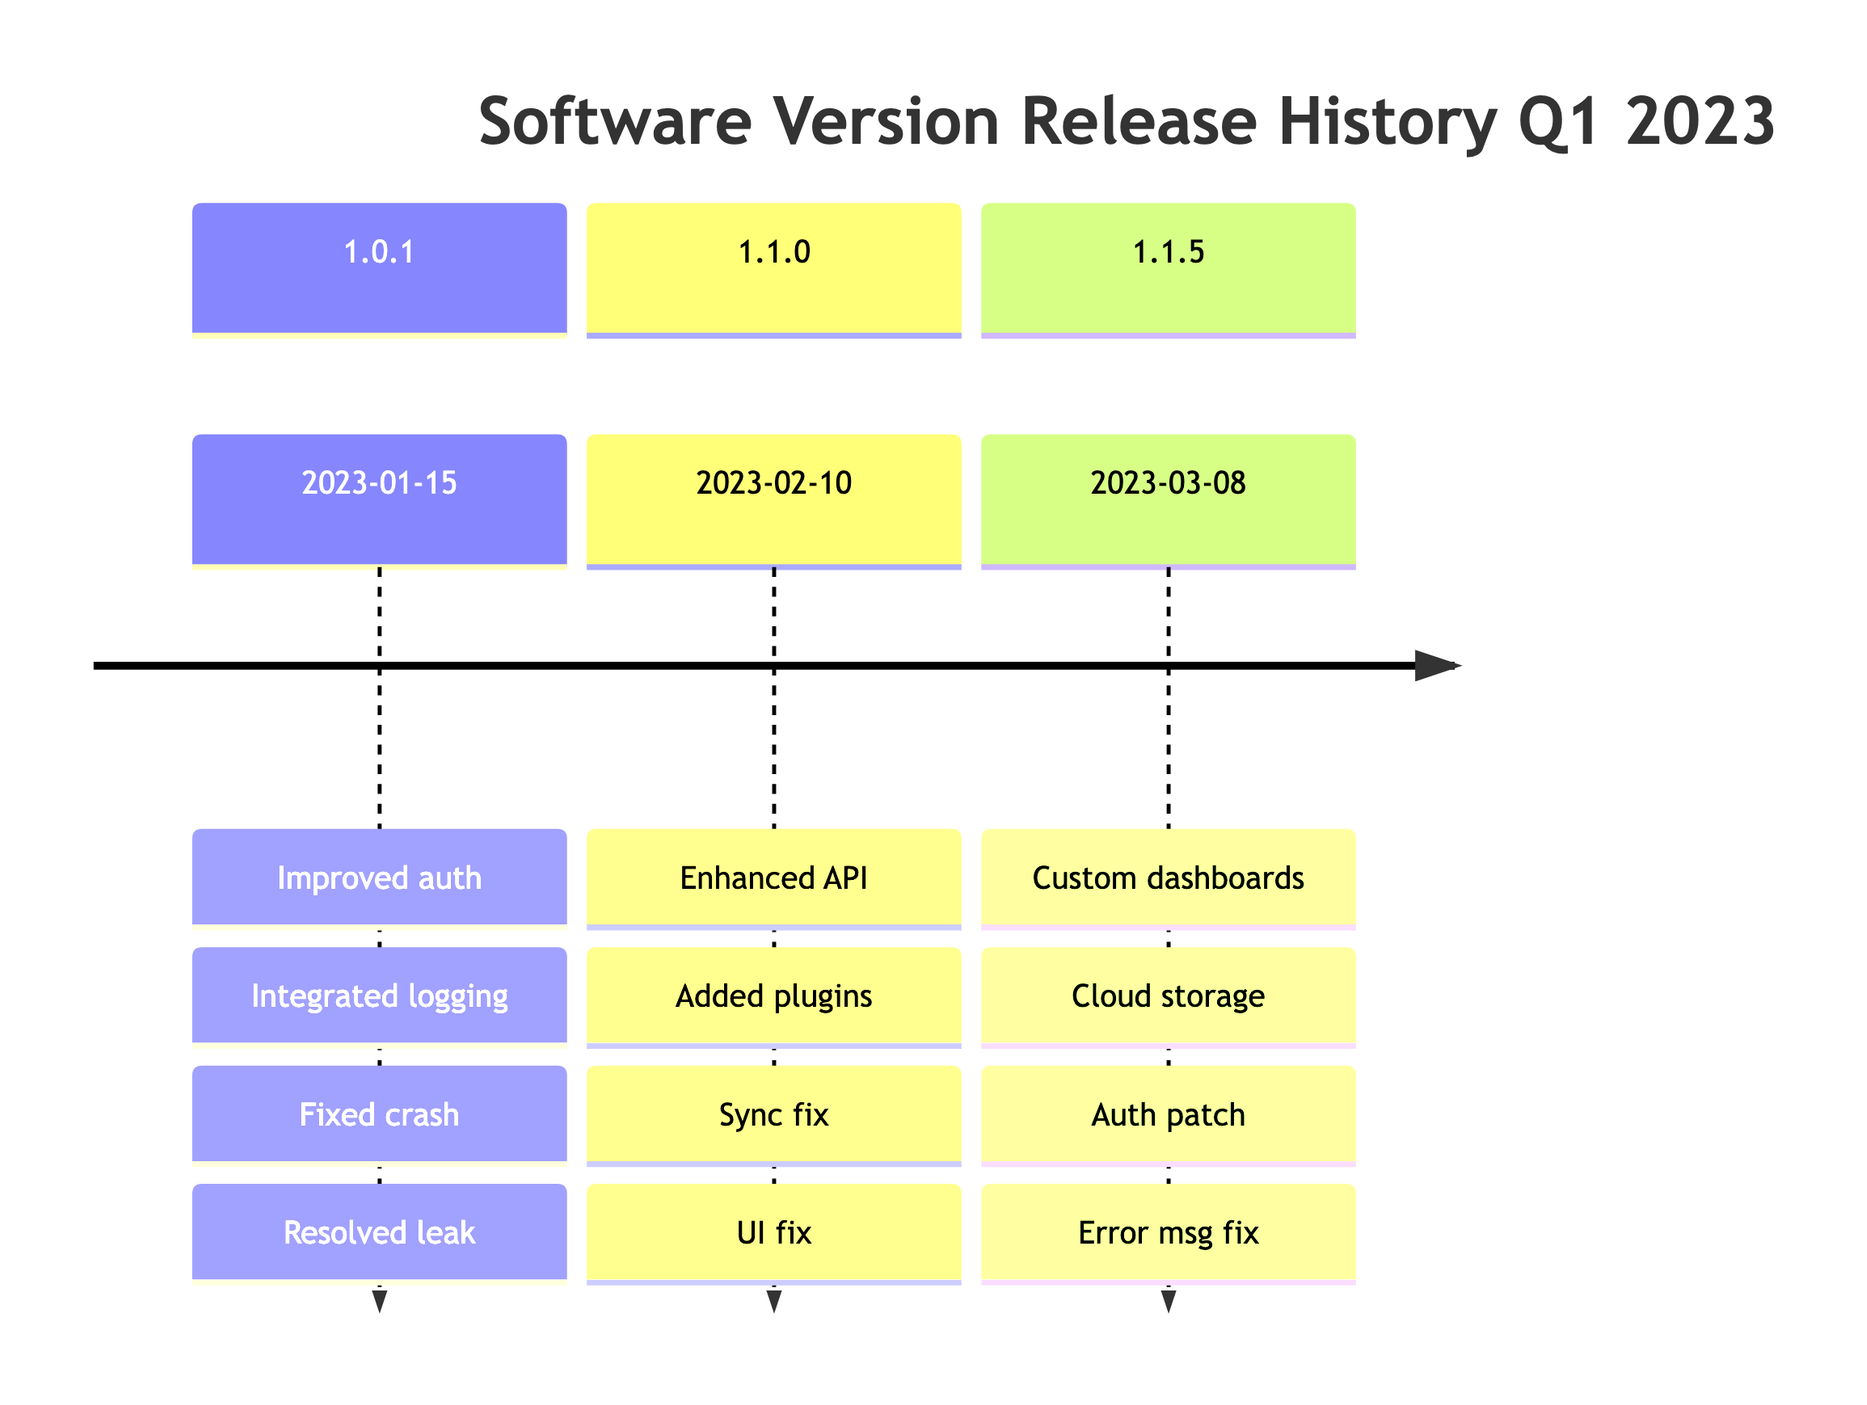What version was released on January 15th, 2023? The timeline indicates that the version released on January 15th, 2023 is 1.0.1.
Answer: 1.0.1 How many bug fixes were included in version 1.1.0? In version 1.1.0, there are two bug fixes listed: "Corrected data synchronization issue" and "Fixed UI glitches in dark mode." Therefore, the total number of bug fixes is 2.
Answer: 2 What feature was added in version 1.1.5? Version 1.1.5 includes two features: "Introduced customizable dashboards" and "Expanded cloud storage options." A specific feature can be "customizable dashboards."
Answer: customizable dashboards Which version fixed the crash on startup for Windows 10? Referring to the timeline, the version that fixed the crash on startup for Windows 10 is 1.0.1.
Answer: 1.0.1 Which feature is related to third-party support? The feature related to third-party support is "Added support for third-party plugins," found in version 1.1.0.
Answer: Added support for third-party plugins What is the release date of version 1.1.0? The timeline specifies that version 1.1.0 was released on February 10th, 2023.
Answer: February 10th, 2023 How many features were introduced in version 1.1.5? Version 1.1.5 introduced two features: "Introduced customizable dashboards" and "Expanded cloud storage options," resulting in a total of 2 features.
Answer: 2 What vulnerability was patched in version 1.1.5? In version 1.1.5, a vulnerability in the authentication module was patched.
Answer: vulnerability in authentication module 